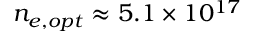Convert formula to latex. <formula><loc_0><loc_0><loc_500><loc_500>n _ { e , o p t } \approx 5 . 1 \times 1 0 ^ { 1 7 }</formula> 